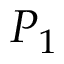Convert formula to latex. <formula><loc_0><loc_0><loc_500><loc_500>P _ { 1 }</formula> 